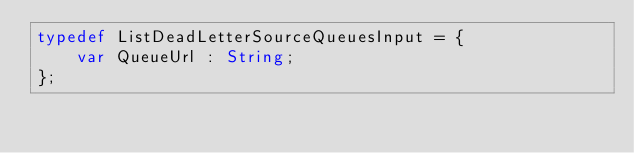Convert code to text. <code><loc_0><loc_0><loc_500><loc_500><_Haxe_>typedef ListDeadLetterSourceQueuesInput = {
    var QueueUrl : String;
};
</code> 